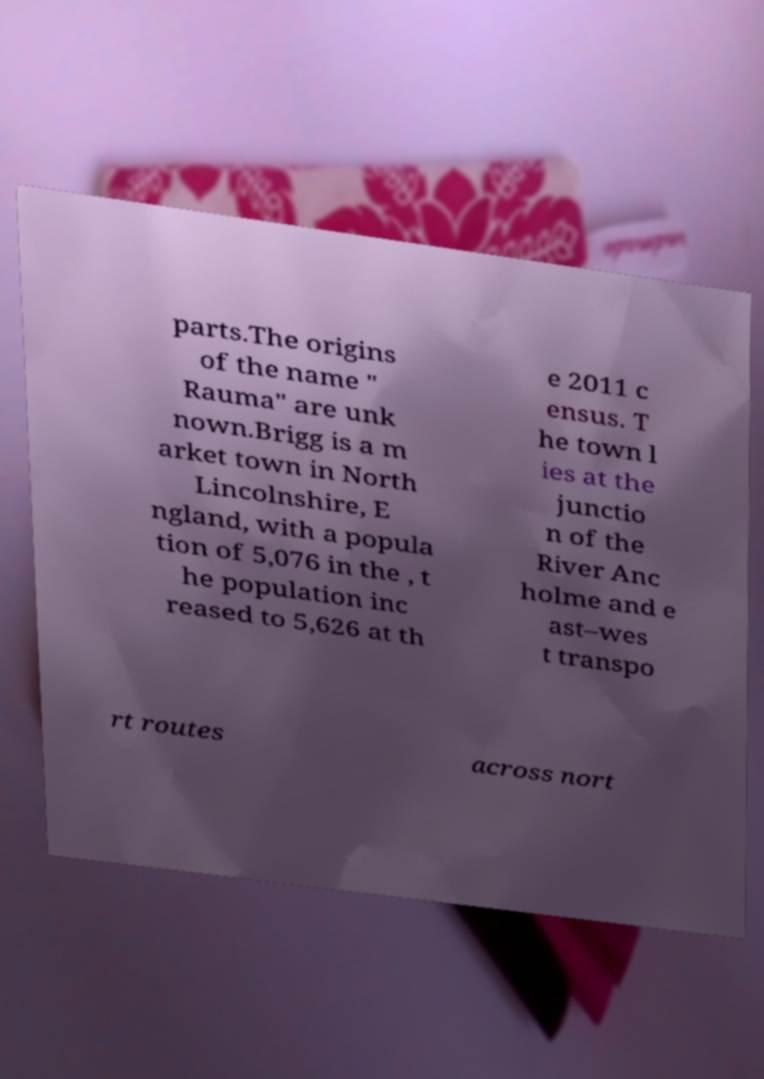I need the written content from this picture converted into text. Can you do that? parts.The origins of the name " Rauma" are unk nown.Brigg is a m arket town in North Lincolnshire, E ngland, with a popula tion of 5,076 in the , t he population inc reased to 5,626 at th e 2011 c ensus. T he town l ies at the junctio n of the River Anc holme and e ast–wes t transpo rt routes across nort 